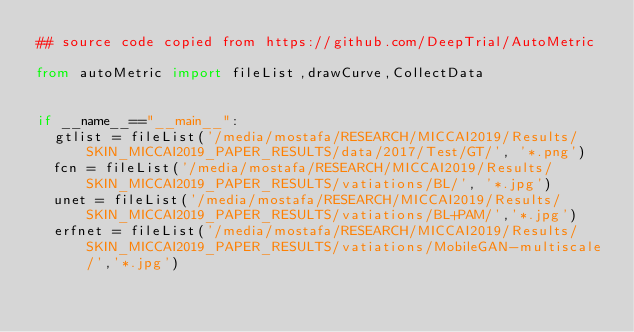Convert code to text. <code><loc_0><loc_0><loc_500><loc_500><_Python_>## source code copied from https://github.com/DeepTrial/AutoMetric

from autoMetric import fileList,drawCurve,CollectData


if __name__=="__main__":
	gtlist = fileList('/media/mostafa/RESEARCH/MICCAI2019/Results/SKIN_MICCAI2019_PAPER_RESULTS/data/2017/Test/GT/', '*.png')
	fcn = fileList('/media/mostafa/RESEARCH/MICCAI2019/Results/SKIN_MICCAI2019_PAPER_RESULTS/vatiations/BL/', '*.jpg')
	unet = fileList('/media/mostafa/RESEARCH/MICCAI2019/Results/SKIN_MICCAI2019_PAPER_RESULTS/vatiations/BL+PAM/','*.jpg')
	erfnet = fileList('/media/mostafa/RESEARCH/MICCAI2019/Results/SKIN_MICCAI2019_PAPER_RESULTS/vatiations/MobileGAN-multiscale/','*.jpg')</code> 